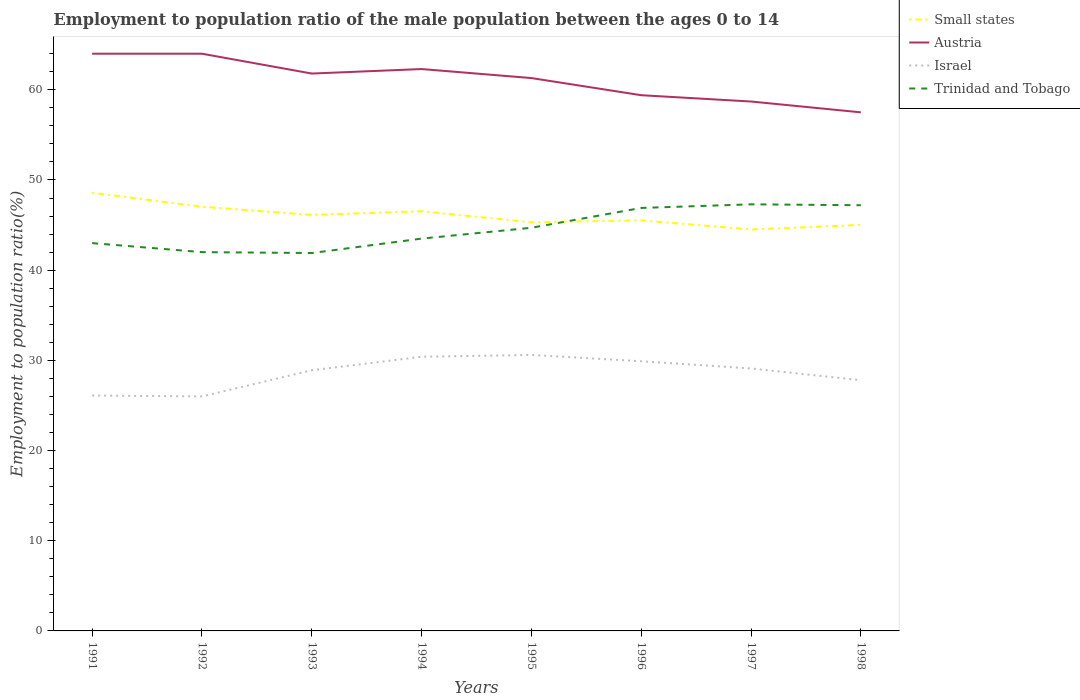Does the line corresponding to Israel intersect with the line corresponding to Austria?
Keep it short and to the point. No. Is the number of lines equal to the number of legend labels?
Provide a succinct answer. Yes. Across all years, what is the maximum employment to population ratio in Austria?
Offer a very short reply. 57.5. In which year was the employment to population ratio in Small states maximum?
Your answer should be very brief. 1997. What is the total employment to population ratio in Small states in the graph?
Your response must be concise. 1.02. What is the difference between the highest and the second highest employment to population ratio in Israel?
Offer a very short reply. 4.6. What is the difference between the highest and the lowest employment to population ratio in Trinidad and Tobago?
Make the answer very short. 4. Is the employment to population ratio in Israel strictly greater than the employment to population ratio in Small states over the years?
Provide a short and direct response. Yes. How many years are there in the graph?
Give a very brief answer. 8. What is the difference between two consecutive major ticks on the Y-axis?
Provide a succinct answer. 10. Are the values on the major ticks of Y-axis written in scientific E-notation?
Your response must be concise. No. Does the graph contain any zero values?
Your answer should be compact. No. Where does the legend appear in the graph?
Keep it short and to the point. Top right. How are the legend labels stacked?
Keep it short and to the point. Vertical. What is the title of the graph?
Provide a short and direct response. Employment to population ratio of the male population between the ages 0 to 14. What is the Employment to population ratio(%) in Small states in 1991?
Offer a very short reply. 48.58. What is the Employment to population ratio(%) of Austria in 1991?
Your answer should be compact. 64. What is the Employment to population ratio(%) of Israel in 1991?
Your response must be concise. 26.1. What is the Employment to population ratio(%) in Small states in 1992?
Your answer should be compact. 47.03. What is the Employment to population ratio(%) in Austria in 1992?
Your answer should be compact. 64. What is the Employment to population ratio(%) of Small states in 1993?
Make the answer very short. 46.13. What is the Employment to population ratio(%) of Austria in 1993?
Your response must be concise. 61.8. What is the Employment to population ratio(%) in Israel in 1993?
Provide a short and direct response. 28.9. What is the Employment to population ratio(%) of Trinidad and Tobago in 1993?
Ensure brevity in your answer.  41.9. What is the Employment to population ratio(%) of Small states in 1994?
Make the answer very short. 46.53. What is the Employment to population ratio(%) in Austria in 1994?
Make the answer very short. 62.3. What is the Employment to population ratio(%) of Israel in 1994?
Your response must be concise. 30.4. What is the Employment to population ratio(%) of Trinidad and Tobago in 1994?
Your response must be concise. 43.5. What is the Employment to population ratio(%) in Small states in 1995?
Provide a short and direct response. 45.31. What is the Employment to population ratio(%) in Austria in 1995?
Keep it short and to the point. 61.3. What is the Employment to population ratio(%) in Israel in 1995?
Your answer should be compact. 30.6. What is the Employment to population ratio(%) in Trinidad and Tobago in 1995?
Provide a short and direct response. 44.7. What is the Employment to population ratio(%) in Small states in 1996?
Your answer should be compact. 45.52. What is the Employment to population ratio(%) in Austria in 1996?
Your answer should be compact. 59.4. What is the Employment to population ratio(%) in Israel in 1996?
Your response must be concise. 29.9. What is the Employment to population ratio(%) of Trinidad and Tobago in 1996?
Ensure brevity in your answer.  46.9. What is the Employment to population ratio(%) in Small states in 1997?
Make the answer very short. 44.51. What is the Employment to population ratio(%) of Austria in 1997?
Offer a very short reply. 58.7. What is the Employment to population ratio(%) in Israel in 1997?
Offer a terse response. 29.1. What is the Employment to population ratio(%) in Trinidad and Tobago in 1997?
Your answer should be compact. 47.3. What is the Employment to population ratio(%) of Small states in 1998?
Provide a succinct answer. 45.02. What is the Employment to population ratio(%) in Austria in 1998?
Offer a very short reply. 57.5. What is the Employment to population ratio(%) in Israel in 1998?
Provide a succinct answer. 27.8. What is the Employment to population ratio(%) in Trinidad and Tobago in 1998?
Your answer should be very brief. 47.2. Across all years, what is the maximum Employment to population ratio(%) of Small states?
Ensure brevity in your answer.  48.58. Across all years, what is the maximum Employment to population ratio(%) of Israel?
Offer a very short reply. 30.6. Across all years, what is the maximum Employment to population ratio(%) of Trinidad and Tobago?
Provide a succinct answer. 47.3. Across all years, what is the minimum Employment to population ratio(%) in Small states?
Make the answer very short. 44.51. Across all years, what is the minimum Employment to population ratio(%) in Austria?
Give a very brief answer. 57.5. Across all years, what is the minimum Employment to population ratio(%) in Trinidad and Tobago?
Your response must be concise. 41.9. What is the total Employment to population ratio(%) of Small states in the graph?
Your response must be concise. 368.64. What is the total Employment to population ratio(%) of Austria in the graph?
Provide a short and direct response. 489. What is the total Employment to population ratio(%) in Israel in the graph?
Make the answer very short. 228.8. What is the total Employment to population ratio(%) in Trinidad and Tobago in the graph?
Give a very brief answer. 356.5. What is the difference between the Employment to population ratio(%) in Small states in 1991 and that in 1992?
Your response must be concise. 1.55. What is the difference between the Employment to population ratio(%) in Austria in 1991 and that in 1992?
Give a very brief answer. 0. What is the difference between the Employment to population ratio(%) in Trinidad and Tobago in 1991 and that in 1992?
Ensure brevity in your answer.  1. What is the difference between the Employment to population ratio(%) of Small states in 1991 and that in 1993?
Keep it short and to the point. 2.45. What is the difference between the Employment to population ratio(%) in Austria in 1991 and that in 1993?
Ensure brevity in your answer.  2.2. What is the difference between the Employment to population ratio(%) in Israel in 1991 and that in 1993?
Offer a terse response. -2.8. What is the difference between the Employment to population ratio(%) of Trinidad and Tobago in 1991 and that in 1993?
Provide a short and direct response. 1.1. What is the difference between the Employment to population ratio(%) of Small states in 1991 and that in 1994?
Your answer should be very brief. 2.05. What is the difference between the Employment to population ratio(%) of Austria in 1991 and that in 1994?
Your answer should be compact. 1.7. What is the difference between the Employment to population ratio(%) of Israel in 1991 and that in 1994?
Your answer should be very brief. -4.3. What is the difference between the Employment to population ratio(%) of Trinidad and Tobago in 1991 and that in 1994?
Your answer should be very brief. -0.5. What is the difference between the Employment to population ratio(%) of Small states in 1991 and that in 1995?
Give a very brief answer. 3.28. What is the difference between the Employment to population ratio(%) of Austria in 1991 and that in 1995?
Offer a terse response. 2.7. What is the difference between the Employment to population ratio(%) in Small states in 1991 and that in 1996?
Your answer should be very brief. 3.06. What is the difference between the Employment to population ratio(%) in Austria in 1991 and that in 1996?
Keep it short and to the point. 4.6. What is the difference between the Employment to population ratio(%) of Small states in 1991 and that in 1997?
Keep it short and to the point. 4.07. What is the difference between the Employment to population ratio(%) of Trinidad and Tobago in 1991 and that in 1997?
Provide a short and direct response. -4.3. What is the difference between the Employment to population ratio(%) in Small states in 1991 and that in 1998?
Your answer should be very brief. 3.56. What is the difference between the Employment to population ratio(%) of Austria in 1991 and that in 1998?
Offer a very short reply. 6.5. What is the difference between the Employment to population ratio(%) in Small states in 1992 and that in 1993?
Offer a terse response. 0.9. What is the difference between the Employment to population ratio(%) of Austria in 1992 and that in 1993?
Keep it short and to the point. 2.2. What is the difference between the Employment to population ratio(%) of Trinidad and Tobago in 1992 and that in 1993?
Give a very brief answer. 0.1. What is the difference between the Employment to population ratio(%) of Small states in 1992 and that in 1994?
Your response must be concise. 0.5. What is the difference between the Employment to population ratio(%) of Austria in 1992 and that in 1994?
Your response must be concise. 1.7. What is the difference between the Employment to population ratio(%) in Small states in 1992 and that in 1995?
Provide a succinct answer. 1.72. What is the difference between the Employment to population ratio(%) of Austria in 1992 and that in 1995?
Provide a short and direct response. 2.7. What is the difference between the Employment to population ratio(%) in Trinidad and Tobago in 1992 and that in 1995?
Provide a succinct answer. -2.7. What is the difference between the Employment to population ratio(%) of Small states in 1992 and that in 1996?
Make the answer very short. 1.51. What is the difference between the Employment to population ratio(%) in Small states in 1992 and that in 1997?
Ensure brevity in your answer.  2.52. What is the difference between the Employment to population ratio(%) of Small states in 1992 and that in 1998?
Offer a terse response. 2.01. What is the difference between the Employment to population ratio(%) of Israel in 1992 and that in 1998?
Your answer should be very brief. -1.8. What is the difference between the Employment to population ratio(%) in Trinidad and Tobago in 1992 and that in 1998?
Your response must be concise. -5.2. What is the difference between the Employment to population ratio(%) in Small states in 1993 and that in 1994?
Offer a very short reply. -0.4. What is the difference between the Employment to population ratio(%) in Trinidad and Tobago in 1993 and that in 1994?
Make the answer very short. -1.6. What is the difference between the Employment to population ratio(%) of Small states in 1993 and that in 1995?
Ensure brevity in your answer.  0.82. What is the difference between the Employment to population ratio(%) of Austria in 1993 and that in 1995?
Offer a terse response. 0.5. What is the difference between the Employment to population ratio(%) in Small states in 1993 and that in 1996?
Provide a short and direct response. 0.6. What is the difference between the Employment to population ratio(%) in Trinidad and Tobago in 1993 and that in 1996?
Offer a very short reply. -5. What is the difference between the Employment to population ratio(%) of Small states in 1993 and that in 1997?
Make the answer very short. 1.62. What is the difference between the Employment to population ratio(%) in Austria in 1993 and that in 1997?
Give a very brief answer. 3.1. What is the difference between the Employment to population ratio(%) of Israel in 1993 and that in 1997?
Offer a very short reply. -0.2. What is the difference between the Employment to population ratio(%) in Trinidad and Tobago in 1993 and that in 1997?
Your response must be concise. -5.4. What is the difference between the Employment to population ratio(%) of Small states in 1993 and that in 1998?
Provide a succinct answer. 1.11. What is the difference between the Employment to population ratio(%) in Austria in 1993 and that in 1998?
Provide a short and direct response. 4.3. What is the difference between the Employment to population ratio(%) in Israel in 1993 and that in 1998?
Offer a very short reply. 1.1. What is the difference between the Employment to population ratio(%) of Trinidad and Tobago in 1993 and that in 1998?
Keep it short and to the point. -5.3. What is the difference between the Employment to population ratio(%) in Small states in 1994 and that in 1995?
Give a very brief answer. 1.23. What is the difference between the Employment to population ratio(%) in Small states in 1994 and that in 1997?
Ensure brevity in your answer.  2.02. What is the difference between the Employment to population ratio(%) of Israel in 1994 and that in 1997?
Ensure brevity in your answer.  1.3. What is the difference between the Employment to population ratio(%) in Small states in 1994 and that in 1998?
Keep it short and to the point. 1.51. What is the difference between the Employment to population ratio(%) in Israel in 1994 and that in 1998?
Your response must be concise. 2.6. What is the difference between the Employment to population ratio(%) in Small states in 1995 and that in 1996?
Make the answer very short. -0.22. What is the difference between the Employment to population ratio(%) of Israel in 1995 and that in 1996?
Make the answer very short. 0.7. What is the difference between the Employment to population ratio(%) of Trinidad and Tobago in 1995 and that in 1996?
Provide a succinct answer. -2.2. What is the difference between the Employment to population ratio(%) of Small states in 1995 and that in 1997?
Keep it short and to the point. 0.8. What is the difference between the Employment to population ratio(%) of Small states in 1995 and that in 1998?
Ensure brevity in your answer.  0.29. What is the difference between the Employment to population ratio(%) of Trinidad and Tobago in 1995 and that in 1998?
Offer a very short reply. -2.5. What is the difference between the Employment to population ratio(%) in Small states in 1996 and that in 1997?
Give a very brief answer. 1.02. What is the difference between the Employment to population ratio(%) of Austria in 1996 and that in 1997?
Offer a very short reply. 0.7. What is the difference between the Employment to population ratio(%) of Small states in 1996 and that in 1998?
Make the answer very short. 0.5. What is the difference between the Employment to population ratio(%) of Israel in 1996 and that in 1998?
Provide a short and direct response. 2.1. What is the difference between the Employment to population ratio(%) in Small states in 1997 and that in 1998?
Offer a very short reply. -0.51. What is the difference between the Employment to population ratio(%) in Israel in 1997 and that in 1998?
Provide a short and direct response. 1.3. What is the difference between the Employment to population ratio(%) in Trinidad and Tobago in 1997 and that in 1998?
Provide a succinct answer. 0.1. What is the difference between the Employment to population ratio(%) in Small states in 1991 and the Employment to population ratio(%) in Austria in 1992?
Offer a very short reply. -15.42. What is the difference between the Employment to population ratio(%) in Small states in 1991 and the Employment to population ratio(%) in Israel in 1992?
Keep it short and to the point. 22.58. What is the difference between the Employment to population ratio(%) in Small states in 1991 and the Employment to population ratio(%) in Trinidad and Tobago in 1992?
Give a very brief answer. 6.58. What is the difference between the Employment to population ratio(%) in Austria in 1991 and the Employment to population ratio(%) in Israel in 1992?
Ensure brevity in your answer.  38. What is the difference between the Employment to population ratio(%) in Israel in 1991 and the Employment to population ratio(%) in Trinidad and Tobago in 1992?
Keep it short and to the point. -15.9. What is the difference between the Employment to population ratio(%) in Small states in 1991 and the Employment to population ratio(%) in Austria in 1993?
Your response must be concise. -13.22. What is the difference between the Employment to population ratio(%) of Small states in 1991 and the Employment to population ratio(%) of Israel in 1993?
Your answer should be very brief. 19.68. What is the difference between the Employment to population ratio(%) of Small states in 1991 and the Employment to population ratio(%) of Trinidad and Tobago in 1993?
Ensure brevity in your answer.  6.68. What is the difference between the Employment to population ratio(%) in Austria in 1991 and the Employment to population ratio(%) in Israel in 1993?
Provide a short and direct response. 35.1. What is the difference between the Employment to population ratio(%) of Austria in 1991 and the Employment to population ratio(%) of Trinidad and Tobago in 1993?
Provide a short and direct response. 22.1. What is the difference between the Employment to population ratio(%) of Israel in 1991 and the Employment to population ratio(%) of Trinidad and Tobago in 1993?
Give a very brief answer. -15.8. What is the difference between the Employment to population ratio(%) of Small states in 1991 and the Employment to population ratio(%) of Austria in 1994?
Give a very brief answer. -13.72. What is the difference between the Employment to population ratio(%) in Small states in 1991 and the Employment to population ratio(%) in Israel in 1994?
Your answer should be very brief. 18.18. What is the difference between the Employment to population ratio(%) in Small states in 1991 and the Employment to population ratio(%) in Trinidad and Tobago in 1994?
Offer a very short reply. 5.08. What is the difference between the Employment to population ratio(%) of Austria in 1991 and the Employment to population ratio(%) of Israel in 1994?
Provide a succinct answer. 33.6. What is the difference between the Employment to population ratio(%) in Austria in 1991 and the Employment to population ratio(%) in Trinidad and Tobago in 1994?
Keep it short and to the point. 20.5. What is the difference between the Employment to population ratio(%) of Israel in 1991 and the Employment to population ratio(%) of Trinidad and Tobago in 1994?
Make the answer very short. -17.4. What is the difference between the Employment to population ratio(%) in Small states in 1991 and the Employment to population ratio(%) in Austria in 1995?
Offer a terse response. -12.72. What is the difference between the Employment to population ratio(%) of Small states in 1991 and the Employment to population ratio(%) of Israel in 1995?
Your answer should be very brief. 17.98. What is the difference between the Employment to population ratio(%) of Small states in 1991 and the Employment to population ratio(%) of Trinidad and Tobago in 1995?
Ensure brevity in your answer.  3.88. What is the difference between the Employment to population ratio(%) of Austria in 1991 and the Employment to population ratio(%) of Israel in 1995?
Make the answer very short. 33.4. What is the difference between the Employment to population ratio(%) in Austria in 1991 and the Employment to population ratio(%) in Trinidad and Tobago in 1995?
Offer a very short reply. 19.3. What is the difference between the Employment to population ratio(%) of Israel in 1991 and the Employment to population ratio(%) of Trinidad and Tobago in 1995?
Give a very brief answer. -18.6. What is the difference between the Employment to population ratio(%) in Small states in 1991 and the Employment to population ratio(%) in Austria in 1996?
Keep it short and to the point. -10.82. What is the difference between the Employment to population ratio(%) of Small states in 1991 and the Employment to population ratio(%) of Israel in 1996?
Ensure brevity in your answer.  18.68. What is the difference between the Employment to population ratio(%) of Small states in 1991 and the Employment to population ratio(%) of Trinidad and Tobago in 1996?
Ensure brevity in your answer.  1.68. What is the difference between the Employment to population ratio(%) in Austria in 1991 and the Employment to population ratio(%) in Israel in 1996?
Your answer should be very brief. 34.1. What is the difference between the Employment to population ratio(%) in Austria in 1991 and the Employment to population ratio(%) in Trinidad and Tobago in 1996?
Your response must be concise. 17.1. What is the difference between the Employment to population ratio(%) in Israel in 1991 and the Employment to population ratio(%) in Trinidad and Tobago in 1996?
Offer a terse response. -20.8. What is the difference between the Employment to population ratio(%) in Small states in 1991 and the Employment to population ratio(%) in Austria in 1997?
Offer a terse response. -10.12. What is the difference between the Employment to population ratio(%) in Small states in 1991 and the Employment to population ratio(%) in Israel in 1997?
Ensure brevity in your answer.  19.48. What is the difference between the Employment to population ratio(%) of Small states in 1991 and the Employment to population ratio(%) of Trinidad and Tobago in 1997?
Your response must be concise. 1.28. What is the difference between the Employment to population ratio(%) in Austria in 1991 and the Employment to population ratio(%) in Israel in 1997?
Your answer should be compact. 34.9. What is the difference between the Employment to population ratio(%) of Austria in 1991 and the Employment to population ratio(%) of Trinidad and Tobago in 1997?
Offer a terse response. 16.7. What is the difference between the Employment to population ratio(%) of Israel in 1991 and the Employment to population ratio(%) of Trinidad and Tobago in 1997?
Provide a succinct answer. -21.2. What is the difference between the Employment to population ratio(%) of Small states in 1991 and the Employment to population ratio(%) of Austria in 1998?
Your answer should be very brief. -8.92. What is the difference between the Employment to population ratio(%) in Small states in 1991 and the Employment to population ratio(%) in Israel in 1998?
Keep it short and to the point. 20.78. What is the difference between the Employment to population ratio(%) in Small states in 1991 and the Employment to population ratio(%) in Trinidad and Tobago in 1998?
Provide a short and direct response. 1.38. What is the difference between the Employment to population ratio(%) of Austria in 1991 and the Employment to population ratio(%) of Israel in 1998?
Your answer should be very brief. 36.2. What is the difference between the Employment to population ratio(%) in Austria in 1991 and the Employment to population ratio(%) in Trinidad and Tobago in 1998?
Give a very brief answer. 16.8. What is the difference between the Employment to population ratio(%) in Israel in 1991 and the Employment to population ratio(%) in Trinidad and Tobago in 1998?
Ensure brevity in your answer.  -21.1. What is the difference between the Employment to population ratio(%) in Small states in 1992 and the Employment to population ratio(%) in Austria in 1993?
Give a very brief answer. -14.77. What is the difference between the Employment to population ratio(%) in Small states in 1992 and the Employment to population ratio(%) in Israel in 1993?
Your answer should be very brief. 18.13. What is the difference between the Employment to population ratio(%) in Small states in 1992 and the Employment to population ratio(%) in Trinidad and Tobago in 1993?
Give a very brief answer. 5.13. What is the difference between the Employment to population ratio(%) of Austria in 1992 and the Employment to population ratio(%) of Israel in 1993?
Give a very brief answer. 35.1. What is the difference between the Employment to population ratio(%) in Austria in 1992 and the Employment to population ratio(%) in Trinidad and Tobago in 1993?
Provide a short and direct response. 22.1. What is the difference between the Employment to population ratio(%) of Israel in 1992 and the Employment to population ratio(%) of Trinidad and Tobago in 1993?
Offer a terse response. -15.9. What is the difference between the Employment to population ratio(%) in Small states in 1992 and the Employment to population ratio(%) in Austria in 1994?
Ensure brevity in your answer.  -15.27. What is the difference between the Employment to population ratio(%) in Small states in 1992 and the Employment to population ratio(%) in Israel in 1994?
Ensure brevity in your answer.  16.63. What is the difference between the Employment to population ratio(%) in Small states in 1992 and the Employment to population ratio(%) in Trinidad and Tobago in 1994?
Your answer should be compact. 3.53. What is the difference between the Employment to population ratio(%) of Austria in 1992 and the Employment to population ratio(%) of Israel in 1994?
Keep it short and to the point. 33.6. What is the difference between the Employment to population ratio(%) of Israel in 1992 and the Employment to population ratio(%) of Trinidad and Tobago in 1994?
Provide a short and direct response. -17.5. What is the difference between the Employment to population ratio(%) in Small states in 1992 and the Employment to population ratio(%) in Austria in 1995?
Your answer should be very brief. -14.27. What is the difference between the Employment to population ratio(%) in Small states in 1992 and the Employment to population ratio(%) in Israel in 1995?
Ensure brevity in your answer.  16.43. What is the difference between the Employment to population ratio(%) of Small states in 1992 and the Employment to population ratio(%) of Trinidad and Tobago in 1995?
Your answer should be compact. 2.33. What is the difference between the Employment to population ratio(%) in Austria in 1992 and the Employment to population ratio(%) in Israel in 1995?
Your response must be concise. 33.4. What is the difference between the Employment to population ratio(%) in Austria in 1992 and the Employment to population ratio(%) in Trinidad and Tobago in 1995?
Give a very brief answer. 19.3. What is the difference between the Employment to population ratio(%) of Israel in 1992 and the Employment to population ratio(%) of Trinidad and Tobago in 1995?
Offer a terse response. -18.7. What is the difference between the Employment to population ratio(%) of Small states in 1992 and the Employment to population ratio(%) of Austria in 1996?
Provide a short and direct response. -12.37. What is the difference between the Employment to population ratio(%) of Small states in 1992 and the Employment to population ratio(%) of Israel in 1996?
Give a very brief answer. 17.13. What is the difference between the Employment to population ratio(%) in Small states in 1992 and the Employment to population ratio(%) in Trinidad and Tobago in 1996?
Make the answer very short. 0.13. What is the difference between the Employment to population ratio(%) in Austria in 1992 and the Employment to population ratio(%) in Israel in 1996?
Offer a terse response. 34.1. What is the difference between the Employment to population ratio(%) in Austria in 1992 and the Employment to population ratio(%) in Trinidad and Tobago in 1996?
Provide a succinct answer. 17.1. What is the difference between the Employment to population ratio(%) in Israel in 1992 and the Employment to population ratio(%) in Trinidad and Tobago in 1996?
Your response must be concise. -20.9. What is the difference between the Employment to population ratio(%) of Small states in 1992 and the Employment to population ratio(%) of Austria in 1997?
Ensure brevity in your answer.  -11.67. What is the difference between the Employment to population ratio(%) in Small states in 1992 and the Employment to population ratio(%) in Israel in 1997?
Provide a succinct answer. 17.93. What is the difference between the Employment to population ratio(%) of Small states in 1992 and the Employment to population ratio(%) of Trinidad and Tobago in 1997?
Ensure brevity in your answer.  -0.27. What is the difference between the Employment to population ratio(%) in Austria in 1992 and the Employment to population ratio(%) in Israel in 1997?
Provide a short and direct response. 34.9. What is the difference between the Employment to population ratio(%) in Israel in 1992 and the Employment to population ratio(%) in Trinidad and Tobago in 1997?
Provide a short and direct response. -21.3. What is the difference between the Employment to population ratio(%) in Small states in 1992 and the Employment to population ratio(%) in Austria in 1998?
Provide a short and direct response. -10.47. What is the difference between the Employment to population ratio(%) in Small states in 1992 and the Employment to population ratio(%) in Israel in 1998?
Your answer should be compact. 19.23. What is the difference between the Employment to population ratio(%) of Small states in 1992 and the Employment to population ratio(%) of Trinidad and Tobago in 1998?
Keep it short and to the point. -0.17. What is the difference between the Employment to population ratio(%) in Austria in 1992 and the Employment to population ratio(%) in Israel in 1998?
Keep it short and to the point. 36.2. What is the difference between the Employment to population ratio(%) of Israel in 1992 and the Employment to population ratio(%) of Trinidad and Tobago in 1998?
Your answer should be compact. -21.2. What is the difference between the Employment to population ratio(%) of Small states in 1993 and the Employment to population ratio(%) of Austria in 1994?
Give a very brief answer. -16.17. What is the difference between the Employment to population ratio(%) of Small states in 1993 and the Employment to population ratio(%) of Israel in 1994?
Make the answer very short. 15.73. What is the difference between the Employment to population ratio(%) in Small states in 1993 and the Employment to population ratio(%) in Trinidad and Tobago in 1994?
Your response must be concise. 2.63. What is the difference between the Employment to population ratio(%) in Austria in 1993 and the Employment to population ratio(%) in Israel in 1994?
Offer a terse response. 31.4. What is the difference between the Employment to population ratio(%) in Austria in 1993 and the Employment to population ratio(%) in Trinidad and Tobago in 1994?
Offer a very short reply. 18.3. What is the difference between the Employment to population ratio(%) of Israel in 1993 and the Employment to population ratio(%) of Trinidad and Tobago in 1994?
Offer a terse response. -14.6. What is the difference between the Employment to population ratio(%) of Small states in 1993 and the Employment to population ratio(%) of Austria in 1995?
Give a very brief answer. -15.17. What is the difference between the Employment to population ratio(%) of Small states in 1993 and the Employment to population ratio(%) of Israel in 1995?
Provide a succinct answer. 15.53. What is the difference between the Employment to population ratio(%) of Small states in 1993 and the Employment to population ratio(%) of Trinidad and Tobago in 1995?
Keep it short and to the point. 1.43. What is the difference between the Employment to population ratio(%) in Austria in 1993 and the Employment to population ratio(%) in Israel in 1995?
Your response must be concise. 31.2. What is the difference between the Employment to population ratio(%) in Israel in 1993 and the Employment to population ratio(%) in Trinidad and Tobago in 1995?
Provide a succinct answer. -15.8. What is the difference between the Employment to population ratio(%) in Small states in 1993 and the Employment to population ratio(%) in Austria in 1996?
Give a very brief answer. -13.27. What is the difference between the Employment to population ratio(%) in Small states in 1993 and the Employment to population ratio(%) in Israel in 1996?
Offer a terse response. 16.23. What is the difference between the Employment to population ratio(%) in Small states in 1993 and the Employment to population ratio(%) in Trinidad and Tobago in 1996?
Ensure brevity in your answer.  -0.77. What is the difference between the Employment to population ratio(%) of Austria in 1993 and the Employment to population ratio(%) of Israel in 1996?
Provide a succinct answer. 31.9. What is the difference between the Employment to population ratio(%) in Israel in 1993 and the Employment to population ratio(%) in Trinidad and Tobago in 1996?
Offer a very short reply. -18. What is the difference between the Employment to population ratio(%) of Small states in 1993 and the Employment to population ratio(%) of Austria in 1997?
Offer a terse response. -12.57. What is the difference between the Employment to population ratio(%) of Small states in 1993 and the Employment to population ratio(%) of Israel in 1997?
Offer a terse response. 17.03. What is the difference between the Employment to population ratio(%) in Small states in 1993 and the Employment to population ratio(%) in Trinidad and Tobago in 1997?
Your response must be concise. -1.17. What is the difference between the Employment to population ratio(%) of Austria in 1993 and the Employment to population ratio(%) of Israel in 1997?
Keep it short and to the point. 32.7. What is the difference between the Employment to population ratio(%) in Israel in 1993 and the Employment to population ratio(%) in Trinidad and Tobago in 1997?
Provide a short and direct response. -18.4. What is the difference between the Employment to population ratio(%) of Small states in 1993 and the Employment to population ratio(%) of Austria in 1998?
Your answer should be very brief. -11.37. What is the difference between the Employment to population ratio(%) in Small states in 1993 and the Employment to population ratio(%) in Israel in 1998?
Keep it short and to the point. 18.33. What is the difference between the Employment to population ratio(%) of Small states in 1993 and the Employment to population ratio(%) of Trinidad and Tobago in 1998?
Offer a very short reply. -1.07. What is the difference between the Employment to population ratio(%) of Austria in 1993 and the Employment to population ratio(%) of Trinidad and Tobago in 1998?
Offer a very short reply. 14.6. What is the difference between the Employment to population ratio(%) in Israel in 1993 and the Employment to population ratio(%) in Trinidad and Tobago in 1998?
Make the answer very short. -18.3. What is the difference between the Employment to population ratio(%) in Small states in 1994 and the Employment to population ratio(%) in Austria in 1995?
Provide a short and direct response. -14.77. What is the difference between the Employment to population ratio(%) in Small states in 1994 and the Employment to population ratio(%) in Israel in 1995?
Your answer should be compact. 15.93. What is the difference between the Employment to population ratio(%) in Small states in 1994 and the Employment to population ratio(%) in Trinidad and Tobago in 1995?
Make the answer very short. 1.83. What is the difference between the Employment to population ratio(%) of Austria in 1994 and the Employment to population ratio(%) of Israel in 1995?
Provide a short and direct response. 31.7. What is the difference between the Employment to population ratio(%) in Israel in 1994 and the Employment to population ratio(%) in Trinidad and Tobago in 1995?
Give a very brief answer. -14.3. What is the difference between the Employment to population ratio(%) in Small states in 1994 and the Employment to population ratio(%) in Austria in 1996?
Your answer should be compact. -12.87. What is the difference between the Employment to population ratio(%) in Small states in 1994 and the Employment to population ratio(%) in Israel in 1996?
Your answer should be compact. 16.63. What is the difference between the Employment to population ratio(%) in Small states in 1994 and the Employment to population ratio(%) in Trinidad and Tobago in 1996?
Your answer should be compact. -0.37. What is the difference between the Employment to population ratio(%) in Austria in 1994 and the Employment to population ratio(%) in Israel in 1996?
Ensure brevity in your answer.  32.4. What is the difference between the Employment to population ratio(%) of Israel in 1994 and the Employment to population ratio(%) of Trinidad and Tobago in 1996?
Offer a very short reply. -16.5. What is the difference between the Employment to population ratio(%) of Small states in 1994 and the Employment to population ratio(%) of Austria in 1997?
Keep it short and to the point. -12.17. What is the difference between the Employment to population ratio(%) in Small states in 1994 and the Employment to population ratio(%) in Israel in 1997?
Keep it short and to the point. 17.43. What is the difference between the Employment to population ratio(%) in Small states in 1994 and the Employment to population ratio(%) in Trinidad and Tobago in 1997?
Give a very brief answer. -0.77. What is the difference between the Employment to population ratio(%) in Austria in 1994 and the Employment to population ratio(%) in Israel in 1997?
Provide a short and direct response. 33.2. What is the difference between the Employment to population ratio(%) in Austria in 1994 and the Employment to population ratio(%) in Trinidad and Tobago in 1997?
Make the answer very short. 15. What is the difference between the Employment to population ratio(%) of Israel in 1994 and the Employment to population ratio(%) of Trinidad and Tobago in 1997?
Your answer should be compact. -16.9. What is the difference between the Employment to population ratio(%) of Small states in 1994 and the Employment to population ratio(%) of Austria in 1998?
Your answer should be very brief. -10.97. What is the difference between the Employment to population ratio(%) of Small states in 1994 and the Employment to population ratio(%) of Israel in 1998?
Offer a very short reply. 18.73. What is the difference between the Employment to population ratio(%) in Small states in 1994 and the Employment to population ratio(%) in Trinidad and Tobago in 1998?
Provide a succinct answer. -0.67. What is the difference between the Employment to population ratio(%) of Austria in 1994 and the Employment to population ratio(%) of Israel in 1998?
Your answer should be very brief. 34.5. What is the difference between the Employment to population ratio(%) of Israel in 1994 and the Employment to population ratio(%) of Trinidad and Tobago in 1998?
Your response must be concise. -16.8. What is the difference between the Employment to population ratio(%) in Small states in 1995 and the Employment to population ratio(%) in Austria in 1996?
Make the answer very short. -14.09. What is the difference between the Employment to population ratio(%) in Small states in 1995 and the Employment to population ratio(%) in Israel in 1996?
Keep it short and to the point. 15.41. What is the difference between the Employment to population ratio(%) of Small states in 1995 and the Employment to population ratio(%) of Trinidad and Tobago in 1996?
Offer a terse response. -1.59. What is the difference between the Employment to population ratio(%) of Austria in 1995 and the Employment to population ratio(%) of Israel in 1996?
Your answer should be very brief. 31.4. What is the difference between the Employment to population ratio(%) in Austria in 1995 and the Employment to population ratio(%) in Trinidad and Tobago in 1996?
Make the answer very short. 14.4. What is the difference between the Employment to population ratio(%) of Israel in 1995 and the Employment to population ratio(%) of Trinidad and Tobago in 1996?
Keep it short and to the point. -16.3. What is the difference between the Employment to population ratio(%) of Small states in 1995 and the Employment to population ratio(%) of Austria in 1997?
Provide a succinct answer. -13.39. What is the difference between the Employment to population ratio(%) of Small states in 1995 and the Employment to population ratio(%) of Israel in 1997?
Offer a terse response. 16.21. What is the difference between the Employment to population ratio(%) of Small states in 1995 and the Employment to population ratio(%) of Trinidad and Tobago in 1997?
Give a very brief answer. -1.99. What is the difference between the Employment to population ratio(%) in Austria in 1995 and the Employment to population ratio(%) in Israel in 1997?
Ensure brevity in your answer.  32.2. What is the difference between the Employment to population ratio(%) in Austria in 1995 and the Employment to population ratio(%) in Trinidad and Tobago in 1997?
Your response must be concise. 14. What is the difference between the Employment to population ratio(%) of Israel in 1995 and the Employment to population ratio(%) of Trinidad and Tobago in 1997?
Provide a succinct answer. -16.7. What is the difference between the Employment to population ratio(%) in Small states in 1995 and the Employment to population ratio(%) in Austria in 1998?
Your response must be concise. -12.19. What is the difference between the Employment to population ratio(%) of Small states in 1995 and the Employment to population ratio(%) of Israel in 1998?
Give a very brief answer. 17.51. What is the difference between the Employment to population ratio(%) of Small states in 1995 and the Employment to population ratio(%) of Trinidad and Tobago in 1998?
Provide a short and direct response. -1.89. What is the difference between the Employment to population ratio(%) in Austria in 1995 and the Employment to population ratio(%) in Israel in 1998?
Your answer should be compact. 33.5. What is the difference between the Employment to population ratio(%) of Austria in 1995 and the Employment to population ratio(%) of Trinidad and Tobago in 1998?
Offer a terse response. 14.1. What is the difference between the Employment to population ratio(%) of Israel in 1995 and the Employment to population ratio(%) of Trinidad and Tobago in 1998?
Give a very brief answer. -16.6. What is the difference between the Employment to population ratio(%) in Small states in 1996 and the Employment to population ratio(%) in Austria in 1997?
Provide a short and direct response. -13.18. What is the difference between the Employment to population ratio(%) of Small states in 1996 and the Employment to population ratio(%) of Israel in 1997?
Provide a short and direct response. 16.42. What is the difference between the Employment to population ratio(%) in Small states in 1996 and the Employment to population ratio(%) in Trinidad and Tobago in 1997?
Give a very brief answer. -1.78. What is the difference between the Employment to population ratio(%) of Austria in 1996 and the Employment to population ratio(%) of Israel in 1997?
Offer a terse response. 30.3. What is the difference between the Employment to population ratio(%) of Israel in 1996 and the Employment to population ratio(%) of Trinidad and Tobago in 1997?
Your answer should be very brief. -17.4. What is the difference between the Employment to population ratio(%) of Small states in 1996 and the Employment to population ratio(%) of Austria in 1998?
Your answer should be very brief. -11.98. What is the difference between the Employment to population ratio(%) of Small states in 1996 and the Employment to population ratio(%) of Israel in 1998?
Give a very brief answer. 17.72. What is the difference between the Employment to population ratio(%) of Small states in 1996 and the Employment to population ratio(%) of Trinidad and Tobago in 1998?
Keep it short and to the point. -1.68. What is the difference between the Employment to population ratio(%) of Austria in 1996 and the Employment to population ratio(%) of Israel in 1998?
Give a very brief answer. 31.6. What is the difference between the Employment to population ratio(%) of Israel in 1996 and the Employment to population ratio(%) of Trinidad and Tobago in 1998?
Offer a terse response. -17.3. What is the difference between the Employment to population ratio(%) in Small states in 1997 and the Employment to population ratio(%) in Austria in 1998?
Your response must be concise. -12.99. What is the difference between the Employment to population ratio(%) of Small states in 1997 and the Employment to population ratio(%) of Israel in 1998?
Give a very brief answer. 16.71. What is the difference between the Employment to population ratio(%) of Small states in 1997 and the Employment to population ratio(%) of Trinidad and Tobago in 1998?
Make the answer very short. -2.69. What is the difference between the Employment to population ratio(%) of Austria in 1997 and the Employment to population ratio(%) of Israel in 1998?
Ensure brevity in your answer.  30.9. What is the difference between the Employment to population ratio(%) of Israel in 1997 and the Employment to population ratio(%) of Trinidad and Tobago in 1998?
Offer a terse response. -18.1. What is the average Employment to population ratio(%) of Small states per year?
Your answer should be compact. 46.08. What is the average Employment to population ratio(%) in Austria per year?
Make the answer very short. 61.12. What is the average Employment to population ratio(%) of Israel per year?
Ensure brevity in your answer.  28.6. What is the average Employment to population ratio(%) of Trinidad and Tobago per year?
Provide a short and direct response. 44.56. In the year 1991, what is the difference between the Employment to population ratio(%) of Small states and Employment to population ratio(%) of Austria?
Give a very brief answer. -15.42. In the year 1991, what is the difference between the Employment to population ratio(%) of Small states and Employment to population ratio(%) of Israel?
Your answer should be very brief. 22.48. In the year 1991, what is the difference between the Employment to population ratio(%) of Small states and Employment to population ratio(%) of Trinidad and Tobago?
Offer a terse response. 5.58. In the year 1991, what is the difference between the Employment to population ratio(%) of Austria and Employment to population ratio(%) of Israel?
Your response must be concise. 37.9. In the year 1991, what is the difference between the Employment to population ratio(%) of Israel and Employment to population ratio(%) of Trinidad and Tobago?
Offer a very short reply. -16.9. In the year 1992, what is the difference between the Employment to population ratio(%) in Small states and Employment to population ratio(%) in Austria?
Your response must be concise. -16.97. In the year 1992, what is the difference between the Employment to population ratio(%) in Small states and Employment to population ratio(%) in Israel?
Your answer should be very brief. 21.03. In the year 1992, what is the difference between the Employment to population ratio(%) of Small states and Employment to population ratio(%) of Trinidad and Tobago?
Keep it short and to the point. 5.03. In the year 1992, what is the difference between the Employment to population ratio(%) in Austria and Employment to population ratio(%) in Israel?
Your response must be concise. 38. In the year 1992, what is the difference between the Employment to population ratio(%) of Austria and Employment to population ratio(%) of Trinidad and Tobago?
Provide a succinct answer. 22. In the year 1993, what is the difference between the Employment to population ratio(%) in Small states and Employment to population ratio(%) in Austria?
Offer a very short reply. -15.67. In the year 1993, what is the difference between the Employment to population ratio(%) in Small states and Employment to population ratio(%) in Israel?
Your response must be concise. 17.23. In the year 1993, what is the difference between the Employment to population ratio(%) in Small states and Employment to population ratio(%) in Trinidad and Tobago?
Your answer should be compact. 4.23. In the year 1993, what is the difference between the Employment to population ratio(%) of Austria and Employment to population ratio(%) of Israel?
Your answer should be compact. 32.9. In the year 1994, what is the difference between the Employment to population ratio(%) in Small states and Employment to population ratio(%) in Austria?
Give a very brief answer. -15.77. In the year 1994, what is the difference between the Employment to population ratio(%) in Small states and Employment to population ratio(%) in Israel?
Provide a short and direct response. 16.13. In the year 1994, what is the difference between the Employment to population ratio(%) of Small states and Employment to population ratio(%) of Trinidad and Tobago?
Your response must be concise. 3.03. In the year 1994, what is the difference between the Employment to population ratio(%) in Austria and Employment to population ratio(%) in Israel?
Provide a short and direct response. 31.9. In the year 1994, what is the difference between the Employment to population ratio(%) in Israel and Employment to population ratio(%) in Trinidad and Tobago?
Make the answer very short. -13.1. In the year 1995, what is the difference between the Employment to population ratio(%) in Small states and Employment to population ratio(%) in Austria?
Ensure brevity in your answer.  -15.99. In the year 1995, what is the difference between the Employment to population ratio(%) of Small states and Employment to population ratio(%) of Israel?
Give a very brief answer. 14.71. In the year 1995, what is the difference between the Employment to population ratio(%) of Small states and Employment to population ratio(%) of Trinidad and Tobago?
Make the answer very short. 0.61. In the year 1995, what is the difference between the Employment to population ratio(%) of Austria and Employment to population ratio(%) of Israel?
Your answer should be very brief. 30.7. In the year 1995, what is the difference between the Employment to population ratio(%) in Israel and Employment to population ratio(%) in Trinidad and Tobago?
Offer a terse response. -14.1. In the year 1996, what is the difference between the Employment to population ratio(%) of Small states and Employment to population ratio(%) of Austria?
Your answer should be compact. -13.88. In the year 1996, what is the difference between the Employment to population ratio(%) of Small states and Employment to population ratio(%) of Israel?
Your answer should be very brief. 15.62. In the year 1996, what is the difference between the Employment to population ratio(%) of Small states and Employment to population ratio(%) of Trinidad and Tobago?
Make the answer very short. -1.38. In the year 1996, what is the difference between the Employment to population ratio(%) in Austria and Employment to population ratio(%) in Israel?
Offer a terse response. 29.5. In the year 1996, what is the difference between the Employment to population ratio(%) in Austria and Employment to population ratio(%) in Trinidad and Tobago?
Your answer should be very brief. 12.5. In the year 1997, what is the difference between the Employment to population ratio(%) of Small states and Employment to population ratio(%) of Austria?
Give a very brief answer. -14.19. In the year 1997, what is the difference between the Employment to population ratio(%) in Small states and Employment to population ratio(%) in Israel?
Provide a succinct answer. 15.41. In the year 1997, what is the difference between the Employment to population ratio(%) of Small states and Employment to population ratio(%) of Trinidad and Tobago?
Provide a short and direct response. -2.79. In the year 1997, what is the difference between the Employment to population ratio(%) of Austria and Employment to population ratio(%) of Israel?
Offer a terse response. 29.6. In the year 1997, what is the difference between the Employment to population ratio(%) in Israel and Employment to population ratio(%) in Trinidad and Tobago?
Keep it short and to the point. -18.2. In the year 1998, what is the difference between the Employment to population ratio(%) in Small states and Employment to population ratio(%) in Austria?
Your answer should be compact. -12.48. In the year 1998, what is the difference between the Employment to population ratio(%) in Small states and Employment to population ratio(%) in Israel?
Keep it short and to the point. 17.22. In the year 1998, what is the difference between the Employment to population ratio(%) of Small states and Employment to population ratio(%) of Trinidad and Tobago?
Your answer should be compact. -2.18. In the year 1998, what is the difference between the Employment to population ratio(%) in Austria and Employment to population ratio(%) in Israel?
Offer a very short reply. 29.7. In the year 1998, what is the difference between the Employment to population ratio(%) of Israel and Employment to population ratio(%) of Trinidad and Tobago?
Your response must be concise. -19.4. What is the ratio of the Employment to population ratio(%) of Small states in 1991 to that in 1992?
Your answer should be compact. 1.03. What is the ratio of the Employment to population ratio(%) in Austria in 1991 to that in 1992?
Your response must be concise. 1. What is the ratio of the Employment to population ratio(%) in Israel in 1991 to that in 1992?
Keep it short and to the point. 1. What is the ratio of the Employment to population ratio(%) of Trinidad and Tobago in 1991 to that in 1992?
Give a very brief answer. 1.02. What is the ratio of the Employment to population ratio(%) in Small states in 1991 to that in 1993?
Make the answer very short. 1.05. What is the ratio of the Employment to population ratio(%) of Austria in 1991 to that in 1993?
Make the answer very short. 1.04. What is the ratio of the Employment to population ratio(%) in Israel in 1991 to that in 1993?
Your answer should be very brief. 0.9. What is the ratio of the Employment to population ratio(%) of Trinidad and Tobago in 1991 to that in 1993?
Keep it short and to the point. 1.03. What is the ratio of the Employment to population ratio(%) of Small states in 1991 to that in 1994?
Ensure brevity in your answer.  1.04. What is the ratio of the Employment to population ratio(%) in Austria in 1991 to that in 1994?
Your response must be concise. 1.03. What is the ratio of the Employment to population ratio(%) in Israel in 1991 to that in 1994?
Offer a very short reply. 0.86. What is the ratio of the Employment to population ratio(%) of Trinidad and Tobago in 1991 to that in 1994?
Your response must be concise. 0.99. What is the ratio of the Employment to population ratio(%) in Small states in 1991 to that in 1995?
Your response must be concise. 1.07. What is the ratio of the Employment to population ratio(%) of Austria in 1991 to that in 1995?
Provide a short and direct response. 1.04. What is the ratio of the Employment to population ratio(%) in Israel in 1991 to that in 1995?
Offer a terse response. 0.85. What is the ratio of the Employment to population ratio(%) of Small states in 1991 to that in 1996?
Keep it short and to the point. 1.07. What is the ratio of the Employment to population ratio(%) of Austria in 1991 to that in 1996?
Ensure brevity in your answer.  1.08. What is the ratio of the Employment to population ratio(%) in Israel in 1991 to that in 1996?
Make the answer very short. 0.87. What is the ratio of the Employment to population ratio(%) of Trinidad and Tobago in 1991 to that in 1996?
Your answer should be compact. 0.92. What is the ratio of the Employment to population ratio(%) in Small states in 1991 to that in 1997?
Give a very brief answer. 1.09. What is the ratio of the Employment to population ratio(%) in Austria in 1991 to that in 1997?
Offer a terse response. 1.09. What is the ratio of the Employment to population ratio(%) in Israel in 1991 to that in 1997?
Your answer should be very brief. 0.9. What is the ratio of the Employment to population ratio(%) of Trinidad and Tobago in 1991 to that in 1997?
Offer a terse response. 0.91. What is the ratio of the Employment to population ratio(%) in Small states in 1991 to that in 1998?
Offer a terse response. 1.08. What is the ratio of the Employment to population ratio(%) in Austria in 1991 to that in 1998?
Offer a terse response. 1.11. What is the ratio of the Employment to population ratio(%) of Israel in 1991 to that in 1998?
Your response must be concise. 0.94. What is the ratio of the Employment to population ratio(%) in Trinidad and Tobago in 1991 to that in 1998?
Give a very brief answer. 0.91. What is the ratio of the Employment to population ratio(%) of Small states in 1992 to that in 1993?
Your answer should be very brief. 1.02. What is the ratio of the Employment to population ratio(%) in Austria in 1992 to that in 1993?
Ensure brevity in your answer.  1.04. What is the ratio of the Employment to population ratio(%) in Israel in 1992 to that in 1993?
Keep it short and to the point. 0.9. What is the ratio of the Employment to population ratio(%) of Small states in 1992 to that in 1994?
Keep it short and to the point. 1.01. What is the ratio of the Employment to population ratio(%) in Austria in 1992 to that in 1994?
Your answer should be compact. 1.03. What is the ratio of the Employment to population ratio(%) in Israel in 1992 to that in 1994?
Provide a short and direct response. 0.86. What is the ratio of the Employment to population ratio(%) in Trinidad and Tobago in 1992 to that in 1994?
Provide a succinct answer. 0.97. What is the ratio of the Employment to population ratio(%) of Small states in 1992 to that in 1995?
Provide a short and direct response. 1.04. What is the ratio of the Employment to population ratio(%) of Austria in 1992 to that in 1995?
Ensure brevity in your answer.  1.04. What is the ratio of the Employment to population ratio(%) in Israel in 1992 to that in 1995?
Ensure brevity in your answer.  0.85. What is the ratio of the Employment to population ratio(%) in Trinidad and Tobago in 1992 to that in 1995?
Your answer should be compact. 0.94. What is the ratio of the Employment to population ratio(%) of Small states in 1992 to that in 1996?
Your answer should be very brief. 1.03. What is the ratio of the Employment to population ratio(%) of Austria in 1992 to that in 1996?
Your response must be concise. 1.08. What is the ratio of the Employment to population ratio(%) of Israel in 1992 to that in 1996?
Keep it short and to the point. 0.87. What is the ratio of the Employment to population ratio(%) of Trinidad and Tobago in 1992 to that in 1996?
Your answer should be compact. 0.9. What is the ratio of the Employment to population ratio(%) of Small states in 1992 to that in 1997?
Offer a terse response. 1.06. What is the ratio of the Employment to population ratio(%) of Austria in 1992 to that in 1997?
Keep it short and to the point. 1.09. What is the ratio of the Employment to population ratio(%) of Israel in 1992 to that in 1997?
Offer a very short reply. 0.89. What is the ratio of the Employment to population ratio(%) in Trinidad and Tobago in 1992 to that in 1997?
Provide a succinct answer. 0.89. What is the ratio of the Employment to population ratio(%) in Small states in 1992 to that in 1998?
Give a very brief answer. 1.04. What is the ratio of the Employment to population ratio(%) of Austria in 1992 to that in 1998?
Your answer should be very brief. 1.11. What is the ratio of the Employment to population ratio(%) in Israel in 1992 to that in 1998?
Make the answer very short. 0.94. What is the ratio of the Employment to population ratio(%) in Trinidad and Tobago in 1992 to that in 1998?
Offer a terse response. 0.89. What is the ratio of the Employment to population ratio(%) of Small states in 1993 to that in 1994?
Make the answer very short. 0.99. What is the ratio of the Employment to population ratio(%) of Israel in 1993 to that in 1994?
Provide a succinct answer. 0.95. What is the ratio of the Employment to population ratio(%) of Trinidad and Tobago in 1993 to that in 1994?
Provide a short and direct response. 0.96. What is the ratio of the Employment to population ratio(%) of Small states in 1993 to that in 1995?
Keep it short and to the point. 1.02. What is the ratio of the Employment to population ratio(%) in Austria in 1993 to that in 1995?
Your response must be concise. 1.01. What is the ratio of the Employment to population ratio(%) in Israel in 1993 to that in 1995?
Keep it short and to the point. 0.94. What is the ratio of the Employment to population ratio(%) in Trinidad and Tobago in 1993 to that in 1995?
Offer a very short reply. 0.94. What is the ratio of the Employment to population ratio(%) in Small states in 1993 to that in 1996?
Provide a short and direct response. 1.01. What is the ratio of the Employment to population ratio(%) of Austria in 1993 to that in 1996?
Provide a short and direct response. 1.04. What is the ratio of the Employment to population ratio(%) of Israel in 1993 to that in 1996?
Your answer should be compact. 0.97. What is the ratio of the Employment to population ratio(%) of Trinidad and Tobago in 1993 to that in 1996?
Offer a very short reply. 0.89. What is the ratio of the Employment to population ratio(%) in Small states in 1993 to that in 1997?
Offer a very short reply. 1.04. What is the ratio of the Employment to population ratio(%) of Austria in 1993 to that in 1997?
Offer a very short reply. 1.05. What is the ratio of the Employment to population ratio(%) in Trinidad and Tobago in 1993 to that in 1997?
Give a very brief answer. 0.89. What is the ratio of the Employment to population ratio(%) of Small states in 1993 to that in 1998?
Offer a terse response. 1.02. What is the ratio of the Employment to population ratio(%) of Austria in 1993 to that in 1998?
Your response must be concise. 1.07. What is the ratio of the Employment to population ratio(%) of Israel in 1993 to that in 1998?
Make the answer very short. 1.04. What is the ratio of the Employment to population ratio(%) of Trinidad and Tobago in 1993 to that in 1998?
Provide a succinct answer. 0.89. What is the ratio of the Employment to population ratio(%) of Austria in 1994 to that in 1995?
Give a very brief answer. 1.02. What is the ratio of the Employment to population ratio(%) of Israel in 1994 to that in 1995?
Give a very brief answer. 0.99. What is the ratio of the Employment to population ratio(%) of Trinidad and Tobago in 1994 to that in 1995?
Keep it short and to the point. 0.97. What is the ratio of the Employment to population ratio(%) of Small states in 1994 to that in 1996?
Ensure brevity in your answer.  1.02. What is the ratio of the Employment to population ratio(%) in Austria in 1994 to that in 1996?
Ensure brevity in your answer.  1.05. What is the ratio of the Employment to population ratio(%) of Israel in 1994 to that in 1996?
Offer a terse response. 1.02. What is the ratio of the Employment to population ratio(%) of Trinidad and Tobago in 1994 to that in 1996?
Keep it short and to the point. 0.93. What is the ratio of the Employment to population ratio(%) in Small states in 1994 to that in 1997?
Provide a succinct answer. 1.05. What is the ratio of the Employment to population ratio(%) in Austria in 1994 to that in 1997?
Keep it short and to the point. 1.06. What is the ratio of the Employment to population ratio(%) in Israel in 1994 to that in 1997?
Keep it short and to the point. 1.04. What is the ratio of the Employment to population ratio(%) in Trinidad and Tobago in 1994 to that in 1997?
Offer a terse response. 0.92. What is the ratio of the Employment to population ratio(%) in Small states in 1994 to that in 1998?
Keep it short and to the point. 1.03. What is the ratio of the Employment to population ratio(%) in Austria in 1994 to that in 1998?
Provide a succinct answer. 1.08. What is the ratio of the Employment to population ratio(%) in Israel in 1994 to that in 1998?
Keep it short and to the point. 1.09. What is the ratio of the Employment to population ratio(%) in Trinidad and Tobago in 1994 to that in 1998?
Your response must be concise. 0.92. What is the ratio of the Employment to population ratio(%) of Small states in 1995 to that in 1996?
Give a very brief answer. 1. What is the ratio of the Employment to population ratio(%) in Austria in 1995 to that in 1996?
Keep it short and to the point. 1.03. What is the ratio of the Employment to population ratio(%) in Israel in 1995 to that in 1996?
Ensure brevity in your answer.  1.02. What is the ratio of the Employment to population ratio(%) of Trinidad and Tobago in 1995 to that in 1996?
Provide a short and direct response. 0.95. What is the ratio of the Employment to population ratio(%) of Small states in 1995 to that in 1997?
Ensure brevity in your answer.  1.02. What is the ratio of the Employment to population ratio(%) of Austria in 1995 to that in 1997?
Offer a terse response. 1.04. What is the ratio of the Employment to population ratio(%) in Israel in 1995 to that in 1997?
Your response must be concise. 1.05. What is the ratio of the Employment to population ratio(%) in Trinidad and Tobago in 1995 to that in 1997?
Give a very brief answer. 0.94. What is the ratio of the Employment to population ratio(%) in Small states in 1995 to that in 1998?
Give a very brief answer. 1.01. What is the ratio of the Employment to population ratio(%) of Austria in 1995 to that in 1998?
Your answer should be compact. 1.07. What is the ratio of the Employment to population ratio(%) of Israel in 1995 to that in 1998?
Your response must be concise. 1.1. What is the ratio of the Employment to population ratio(%) in Trinidad and Tobago in 1995 to that in 1998?
Offer a terse response. 0.95. What is the ratio of the Employment to population ratio(%) in Small states in 1996 to that in 1997?
Ensure brevity in your answer.  1.02. What is the ratio of the Employment to population ratio(%) in Austria in 1996 to that in 1997?
Your answer should be very brief. 1.01. What is the ratio of the Employment to population ratio(%) of Israel in 1996 to that in 1997?
Provide a succinct answer. 1.03. What is the ratio of the Employment to population ratio(%) of Small states in 1996 to that in 1998?
Your response must be concise. 1.01. What is the ratio of the Employment to population ratio(%) of Austria in 1996 to that in 1998?
Your answer should be compact. 1.03. What is the ratio of the Employment to population ratio(%) in Israel in 1996 to that in 1998?
Give a very brief answer. 1.08. What is the ratio of the Employment to population ratio(%) in Austria in 1997 to that in 1998?
Offer a very short reply. 1.02. What is the ratio of the Employment to population ratio(%) of Israel in 1997 to that in 1998?
Keep it short and to the point. 1.05. What is the difference between the highest and the second highest Employment to population ratio(%) of Small states?
Provide a succinct answer. 1.55. What is the difference between the highest and the second highest Employment to population ratio(%) of Austria?
Give a very brief answer. 0. What is the difference between the highest and the second highest Employment to population ratio(%) in Israel?
Your answer should be very brief. 0.2. What is the difference between the highest and the lowest Employment to population ratio(%) of Small states?
Keep it short and to the point. 4.07. What is the difference between the highest and the lowest Employment to population ratio(%) in Israel?
Provide a short and direct response. 4.6. What is the difference between the highest and the lowest Employment to population ratio(%) of Trinidad and Tobago?
Offer a very short reply. 5.4. 